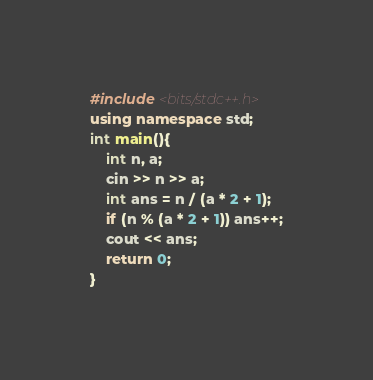Convert code to text. <code><loc_0><loc_0><loc_500><loc_500><_C++_>#include <bits/stdc++.h>
using namespace std;
int main(){
	int n, a;
	cin >> n >> a;
	int ans = n / (a * 2 + 1);
	if (n % (a * 2 + 1)) ans++;
	cout << ans;
	return 0;
} </code> 